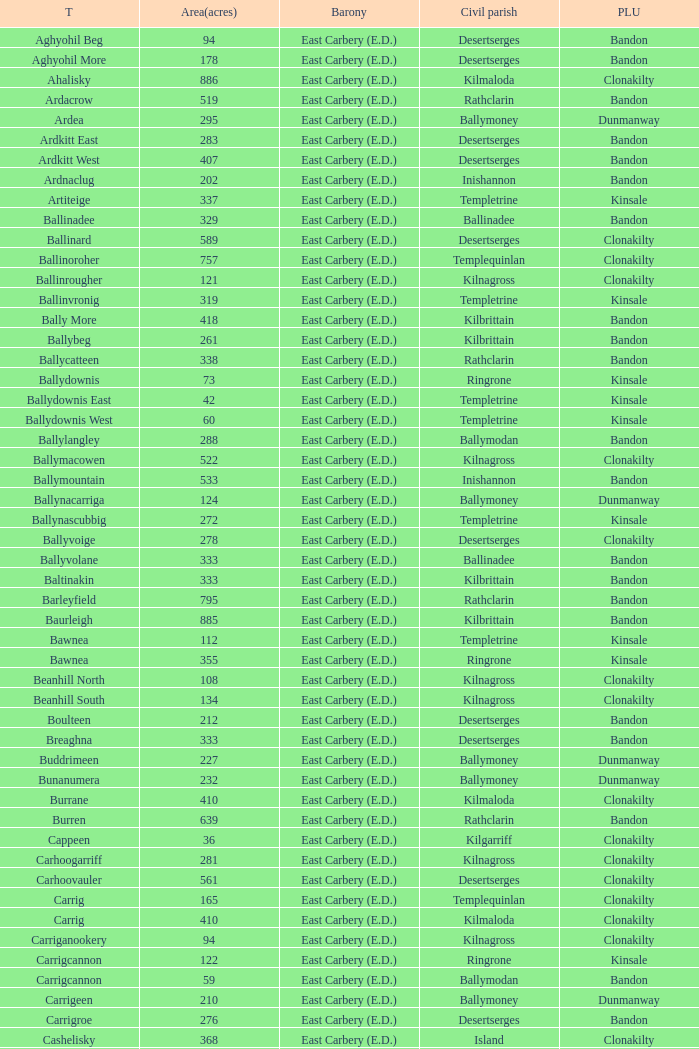What is the poor law union of the Lackenagobidane townland? Clonakilty. Parse the table in full. {'header': ['T', 'Area(acres)', 'Barony', 'Civil parish', 'PLU'], 'rows': [['Aghyohil Beg', '94', 'East Carbery (E.D.)', 'Desertserges', 'Bandon'], ['Aghyohil More', '178', 'East Carbery (E.D.)', 'Desertserges', 'Bandon'], ['Ahalisky', '886', 'East Carbery (E.D.)', 'Kilmaloda', 'Clonakilty'], ['Ardacrow', '519', 'East Carbery (E.D.)', 'Rathclarin', 'Bandon'], ['Ardea', '295', 'East Carbery (E.D.)', 'Ballymoney', 'Dunmanway'], ['Ardkitt East', '283', 'East Carbery (E.D.)', 'Desertserges', 'Bandon'], ['Ardkitt West', '407', 'East Carbery (E.D.)', 'Desertserges', 'Bandon'], ['Ardnaclug', '202', 'East Carbery (E.D.)', 'Inishannon', 'Bandon'], ['Artiteige', '337', 'East Carbery (E.D.)', 'Templetrine', 'Kinsale'], ['Ballinadee', '329', 'East Carbery (E.D.)', 'Ballinadee', 'Bandon'], ['Ballinard', '589', 'East Carbery (E.D.)', 'Desertserges', 'Clonakilty'], ['Ballinoroher', '757', 'East Carbery (E.D.)', 'Templequinlan', 'Clonakilty'], ['Ballinrougher', '121', 'East Carbery (E.D.)', 'Kilnagross', 'Clonakilty'], ['Ballinvronig', '319', 'East Carbery (E.D.)', 'Templetrine', 'Kinsale'], ['Bally More', '418', 'East Carbery (E.D.)', 'Kilbrittain', 'Bandon'], ['Ballybeg', '261', 'East Carbery (E.D.)', 'Kilbrittain', 'Bandon'], ['Ballycatteen', '338', 'East Carbery (E.D.)', 'Rathclarin', 'Bandon'], ['Ballydownis', '73', 'East Carbery (E.D.)', 'Ringrone', 'Kinsale'], ['Ballydownis East', '42', 'East Carbery (E.D.)', 'Templetrine', 'Kinsale'], ['Ballydownis West', '60', 'East Carbery (E.D.)', 'Templetrine', 'Kinsale'], ['Ballylangley', '288', 'East Carbery (E.D.)', 'Ballymodan', 'Bandon'], ['Ballymacowen', '522', 'East Carbery (E.D.)', 'Kilnagross', 'Clonakilty'], ['Ballymountain', '533', 'East Carbery (E.D.)', 'Inishannon', 'Bandon'], ['Ballynacarriga', '124', 'East Carbery (E.D.)', 'Ballymoney', 'Dunmanway'], ['Ballynascubbig', '272', 'East Carbery (E.D.)', 'Templetrine', 'Kinsale'], ['Ballyvoige', '278', 'East Carbery (E.D.)', 'Desertserges', 'Clonakilty'], ['Ballyvolane', '333', 'East Carbery (E.D.)', 'Ballinadee', 'Bandon'], ['Baltinakin', '333', 'East Carbery (E.D.)', 'Kilbrittain', 'Bandon'], ['Barleyfield', '795', 'East Carbery (E.D.)', 'Rathclarin', 'Bandon'], ['Baurleigh', '885', 'East Carbery (E.D.)', 'Kilbrittain', 'Bandon'], ['Bawnea', '112', 'East Carbery (E.D.)', 'Templetrine', 'Kinsale'], ['Bawnea', '355', 'East Carbery (E.D.)', 'Ringrone', 'Kinsale'], ['Beanhill North', '108', 'East Carbery (E.D.)', 'Kilnagross', 'Clonakilty'], ['Beanhill South', '134', 'East Carbery (E.D.)', 'Kilnagross', 'Clonakilty'], ['Boulteen', '212', 'East Carbery (E.D.)', 'Desertserges', 'Bandon'], ['Breaghna', '333', 'East Carbery (E.D.)', 'Desertserges', 'Bandon'], ['Buddrimeen', '227', 'East Carbery (E.D.)', 'Ballymoney', 'Dunmanway'], ['Bunanumera', '232', 'East Carbery (E.D.)', 'Ballymoney', 'Dunmanway'], ['Burrane', '410', 'East Carbery (E.D.)', 'Kilmaloda', 'Clonakilty'], ['Burren', '639', 'East Carbery (E.D.)', 'Rathclarin', 'Bandon'], ['Cappeen', '36', 'East Carbery (E.D.)', 'Kilgarriff', 'Clonakilty'], ['Carhoogarriff', '281', 'East Carbery (E.D.)', 'Kilnagross', 'Clonakilty'], ['Carhoovauler', '561', 'East Carbery (E.D.)', 'Desertserges', 'Clonakilty'], ['Carrig', '165', 'East Carbery (E.D.)', 'Templequinlan', 'Clonakilty'], ['Carrig', '410', 'East Carbery (E.D.)', 'Kilmaloda', 'Clonakilty'], ['Carriganookery', '94', 'East Carbery (E.D.)', 'Kilnagross', 'Clonakilty'], ['Carrigcannon', '122', 'East Carbery (E.D.)', 'Ringrone', 'Kinsale'], ['Carrigcannon', '59', 'East Carbery (E.D.)', 'Ballymodan', 'Bandon'], ['Carrigeen', '210', 'East Carbery (E.D.)', 'Ballymoney', 'Dunmanway'], ['Carrigroe', '276', 'East Carbery (E.D.)', 'Desertserges', 'Bandon'], ['Cashelisky', '368', 'East Carbery (E.D.)', 'Island', 'Clonakilty'], ['Castlederry', '148', 'East Carbery (E.D.)', 'Desertserges', 'Clonakilty'], ['Clashafree', '477', 'East Carbery (E.D.)', 'Ballymodan', 'Bandon'], ['Clashreagh', '132', 'East Carbery (E.D.)', 'Templetrine', 'Kinsale'], ['Clogagh North', '173', 'East Carbery (E.D.)', 'Kilmaloda', 'Clonakilty'], ['Clogagh South', '282', 'East Carbery (E.D.)', 'Kilmaloda', 'Clonakilty'], ['Cloghane', '488', 'East Carbery (E.D.)', 'Ballinadee', 'Bandon'], ['Clogheenavodig', '70', 'East Carbery (E.D.)', 'Ballymodan', 'Bandon'], ['Cloghmacsimon', '258', 'East Carbery (E.D.)', 'Ballymodan', 'Bandon'], ['Cloheen', '360', 'East Carbery (E.D.)', 'Kilgarriff', 'Clonakilty'], ['Cloheen', '80', 'East Carbery (E.D.)', 'Island', 'Clonakilty'], ['Clonbouig', '209', 'East Carbery (E.D.)', 'Templetrine', 'Kinsale'], ['Clonbouig', '219', 'East Carbery (E.D.)', 'Ringrone', 'Kinsale'], ['Cloncouse', '241', 'East Carbery (E.D.)', 'Ballinadee', 'Bandon'], ['Clooncalla Beg', '219', 'East Carbery (E.D.)', 'Rathclarin', 'Bandon'], ['Clooncalla More', '543', 'East Carbery (E.D.)', 'Rathclarin', 'Bandon'], ['Cloonderreen', '291', 'East Carbery (E.D.)', 'Rathclarin', 'Bandon'], ['Coolmain', '450', 'East Carbery (E.D.)', 'Ringrone', 'Kinsale'], ['Corravreeda East', '258', 'East Carbery (E.D.)', 'Ballymodan', 'Bandon'], ['Corravreeda West', '169', 'East Carbery (E.D.)', 'Ballymodan', 'Bandon'], ['Cripplehill', '125', 'East Carbery (E.D.)', 'Ballymodan', 'Bandon'], ['Cripplehill', '93', 'East Carbery (E.D.)', 'Kilbrittain', 'Bandon'], ['Crohane', '91', 'East Carbery (E.D.)', 'Kilnagross', 'Clonakilty'], ['Crohane East', '108', 'East Carbery (E.D.)', 'Desertserges', 'Clonakilty'], ['Crohane West', '69', 'East Carbery (E.D.)', 'Desertserges', 'Clonakilty'], ['Crohane (or Bandon)', '204', 'East Carbery (E.D.)', 'Desertserges', 'Clonakilty'], ['Crohane (or Bandon)', '250', 'East Carbery (E.D.)', 'Kilnagross', 'Clonakilty'], ['Currabeg', '173', 'East Carbery (E.D.)', 'Ballymoney', 'Dunmanway'], ['Curraghcrowly East', '327', 'East Carbery (E.D.)', 'Ballymoney', 'Dunmanway'], ['Curraghcrowly West', '242', 'East Carbery (E.D.)', 'Ballymoney', 'Dunmanway'], ['Curraghgrane More', '110', 'East Carbery (E.D.)', 'Desert', 'Clonakilty'], ['Currane', '156', 'East Carbery (E.D.)', 'Desertserges', 'Clonakilty'], ['Curranure', '362', 'East Carbery (E.D.)', 'Inishannon', 'Bandon'], ['Currarane', '100', 'East Carbery (E.D.)', 'Templetrine', 'Kinsale'], ['Currarane', '271', 'East Carbery (E.D.)', 'Ringrone', 'Kinsale'], ['Derrigra', '177', 'East Carbery (E.D.)', 'Ballymoney', 'Dunmanway'], ['Derrigra West', '320', 'East Carbery (E.D.)', 'Ballymoney', 'Dunmanway'], ['Derry', '140', 'East Carbery (E.D.)', 'Desertserges', 'Clonakilty'], ['Derrymeeleen', '441', 'East Carbery (E.D.)', 'Desertserges', 'Clonakilty'], ['Desert', '339', 'East Carbery (E.D.)', 'Desert', 'Clonakilty'], ['Drombofinny', '86', 'East Carbery (E.D.)', 'Desertserges', 'Bandon'], ['Dromgarriff', '335', 'East Carbery (E.D.)', 'Kilmaloda', 'Clonakilty'], ['Dromgarriff East', '385', 'East Carbery (E.D.)', 'Kilnagross', 'Clonakilty'], ['Dromgarriff West', '138', 'East Carbery (E.D.)', 'Kilnagross', 'Clonakilty'], ['Dromkeen', '673', 'East Carbery (E.D.)', 'Inishannon', 'Bandon'], ['Edencurra', '516', 'East Carbery (E.D.)', 'Ballymoney', 'Dunmanway'], ['Farran', '502', 'East Carbery (E.D.)', 'Kilmaloda', 'Clonakilty'], ['Farranagow', '99', 'East Carbery (E.D.)', 'Inishannon', 'Bandon'], ['Farrannagark', '290', 'East Carbery (E.D.)', 'Rathclarin', 'Bandon'], ['Farrannasheshery', '304', 'East Carbery (E.D.)', 'Desertserges', 'Bandon'], ['Fourcuil', '125', 'East Carbery (E.D.)', 'Kilgarriff', 'Clonakilty'], ['Fourcuil', '244', 'East Carbery (E.D.)', 'Templebryan', 'Clonakilty'], ['Garranbeg', '170', 'East Carbery (E.D.)', 'Ballymodan', 'Bandon'], ['Garraneanasig', '270', 'East Carbery (E.D.)', 'Ringrone', 'Kinsale'], ['Garraneard', '276', 'East Carbery (E.D.)', 'Kilnagross', 'Clonakilty'], ['Garranecore', '144', 'East Carbery (E.D.)', 'Templebryan', 'Clonakilty'], ['Garranecore', '186', 'East Carbery (E.D.)', 'Kilgarriff', 'Clonakilty'], ['Garranefeen', '478', 'East Carbery (E.D.)', 'Rathclarin', 'Bandon'], ['Garraneishal', '121', 'East Carbery (E.D.)', 'Kilnagross', 'Clonakilty'], ['Garranelahan', '126', 'East Carbery (E.D.)', 'Desertserges', 'Bandon'], ['Garranereagh', '398', 'East Carbery (E.D.)', 'Ringrone', 'Kinsale'], ['Garranes', '416', 'East Carbery (E.D.)', 'Desertserges', 'Clonakilty'], ['Garranure', '436', 'East Carbery (E.D.)', 'Ballymoney', 'Dunmanway'], ['Garryndruig', '856', 'East Carbery (E.D.)', 'Rathclarin', 'Bandon'], ['Glan', '194', 'East Carbery (E.D.)', 'Ballymoney', 'Dunmanway'], ['Glanavaud', '98', 'East Carbery (E.D.)', 'Ringrone', 'Kinsale'], ['Glanavirane', '107', 'East Carbery (E.D.)', 'Templetrine', 'Kinsale'], ['Glanavirane', '91', 'East Carbery (E.D.)', 'Ringrone', 'Kinsale'], ['Glanduff', '464', 'East Carbery (E.D.)', 'Rathclarin', 'Bandon'], ['Grillagh', '136', 'East Carbery (E.D.)', 'Kilnagross', 'Clonakilty'], ['Grillagh', '316', 'East Carbery (E.D.)', 'Ballymoney', 'Dunmanway'], ['Hacketstown', '182', 'East Carbery (E.D.)', 'Templetrine', 'Kinsale'], ['Inchafune', '871', 'East Carbery (E.D.)', 'Ballymoney', 'Dunmanway'], ['Inchydoney Island', '474', 'East Carbery (E.D.)', 'Island', 'Clonakilty'], ['Kilbeloge', '216', 'East Carbery (E.D.)', 'Desertserges', 'Clonakilty'], ['Kilbree', '284', 'East Carbery (E.D.)', 'Island', 'Clonakilty'], ['Kilbrittain', '483', 'East Carbery (E.D.)', 'Kilbrittain', 'Bandon'], ['Kilcaskan', '221', 'East Carbery (E.D.)', 'Ballymoney', 'Dunmanway'], ['Kildarra', '463', 'East Carbery (E.D.)', 'Ballinadee', 'Bandon'], ['Kilgarriff', '835', 'East Carbery (E.D.)', 'Kilgarriff', 'Clonakilty'], ['Kilgobbin', '1263', 'East Carbery (E.D.)', 'Ballinadee', 'Bandon'], ['Kill North', '136', 'East Carbery (E.D.)', 'Desertserges', 'Clonakilty'], ['Kill South', '139', 'East Carbery (E.D.)', 'Desertserges', 'Clonakilty'], ['Killanamaul', '220', 'East Carbery (E.D.)', 'Kilbrittain', 'Bandon'], ['Killaneetig', '342', 'East Carbery (E.D.)', 'Ballinadee', 'Bandon'], ['Killavarrig', '708', 'East Carbery (E.D.)', 'Timoleague', 'Clonakilty'], ['Killeen', '309', 'East Carbery (E.D.)', 'Desertserges', 'Clonakilty'], ['Killeens', '132', 'East Carbery (E.D.)', 'Templetrine', 'Kinsale'], ['Kilmacsimon', '219', 'East Carbery (E.D.)', 'Ballinadee', 'Bandon'], ['Kilmaloda', '634', 'East Carbery (E.D.)', 'Kilmaloda', 'Clonakilty'], ['Kilmoylerane North', '306', 'East Carbery (E.D.)', 'Desertserges', 'Clonakilty'], ['Kilmoylerane South', '324', 'East Carbery (E.D.)', 'Desertserges', 'Clonakilty'], ['Kilnameela', '397', 'East Carbery (E.D.)', 'Desertserges', 'Bandon'], ['Kilrush', '189', 'East Carbery (E.D.)', 'Desertserges', 'Bandon'], ['Kilshinahan', '528', 'East Carbery (E.D.)', 'Kilbrittain', 'Bandon'], ['Kilvinane', '199', 'East Carbery (E.D.)', 'Ballymoney', 'Dunmanway'], ['Kilvurra', '356', 'East Carbery (E.D.)', 'Ballymoney', 'Dunmanway'], ['Knockacullen', '381', 'East Carbery (E.D.)', 'Desertserges', 'Clonakilty'], ['Knockaneady', '393', 'East Carbery (E.D.)', 'Ballymoney', 'Dunmanway'], ['Knockaneroe', '127', 'East Carbery (E.D.)', 'Templetrine', 'Kinsale'], ['Knockanreagh', '139', 'East Carbery (E.D.)', 'Ballymodan', 'Bandon'], ['Knockbrown', '312', 'East Carbery (E.D.)', 'Kilbrittain', 'Bandon'], ['Knockbrown', '510', 'East Carbery (E.D.)', 'Kilmaloda', 'Bandon'], ['Knockeenbwee Lower', '213', 'East Carbery (E.D.)', 'Dromdaleague', 'Skibbereen'], ['Knockeenbwee Upper', '229', 'East Carbery (E.D.)', 'Dromdaleague', 'Skibbereen'], ['Knockeencon', '108', 'East Carbery (E.D.)', 'Tullagh', 'Skibbereen'], ['Knockmacool', '241', 'East Carbery (E.D.)', 'Desertserges', 'Bandon'], ['Knocknacurra', '422', 'East Carbery (E.D.)', 'Ballinadee', 'Bandon'], ['Knocknagappul', '507', 'East Carbery (E.D.)', 'Ballinadee', 'Bandon'], ['Knocknanuss', '394', 'East Carbery (E.D.)', 'Desertserges', 'Clonakilty'], ['Knocknastooka', '118', 'East Carbery (E.D.)', 'Desertserges', 'Bandon'], ['Knockroe', '601', 'East Carbery (E.D.)', 'Inishannon', 'Bandon'], ['Knocks', '540', 'East Carbery (E.D.)', 'Desertserges', 'Clonakilty'], ['Knockskagh', '489', 'East Carbery (E.D.)', 'Kilgarriff', 'Clonakilty'], ['Knoppoge', '567', 'East Carbery (E.D.)', 'Kilbrittain', 'Bandon'], ['Lackanalooha', '209', 'East Carbery (E.D.)', 'Kilnagross', 'Clonakilty'], ['Lackenagobidane', '48', 'East Carbery (E.D.)', 'Island', 'Clonakilty'], ['Lisbehegh', '255', 'East Carbery (E.D.)', 'Desertserges', 'Clonakilty'], ['Lisheen', '44', 'East Carbery (E.D.)', 'Templetrine', 'Kinsale'], ['Lisheenaleen', '267', 'East Carbery (E.D.)', 'Rathclarin', 'Bandon'], ['Lisnacunna', '529', 'East Carbery (E.D.)', 'Desertserges', 'Bandon'], ['Lisroe', '91', 'East Carbery (E.D.)', 'Kilgarriff', 'Clonakilty'], ['Lissaphooca', '513', 'East Carbery (E.D.)', 'Ballymodan', 'Bandon'], ['Lisselane', '429', 'East Carbery (E.D.)', 'Kilnagross', 'Clonakilty'], ['Madame', '273', 'East Carbery (E.D.)', 'Kilmaloda', 'Clonakilty'], ['Madame', '41', 'East Carbery (E.D.)', 'Kilnagross', 'Clonakilty'], ['Maulbrack East', '100', 'East Carbery (E.D.)', 'Desertserges', 'Bandon'], ['Maulbrack West', '242', 'East Carbery (E.D.)', 'Desertserges', 'Bandon'], ['Maulmane', '219', 'East Carbery (E.D.)', 'Kilbrittain', 'Bandon'], ['Maulnageragh', '135', 'East Carbery (E.D.)', 'Kilnagross', 'Clonakilty'], ['Maulnarouga North', '81', 'East Carbery (E.D.)', 'Desertserges', 'Bandon'], ['Maulnarouga South', '374', 'East Carbery (E.D.)', 'Desertserges', 'Bandon'], ['Maulnaskehy', '14', 'East Carbery (E.D.)', 'Kilgarriff', 'Clonakilty'], ['Maulrour', '244', 'East Carbery (E.D.)', 'Desertserges', 'Clonakilty'], ['Maulrour', '340', 'East Carbery (E.D.)', 'Kilmaloda', 'Clonakilty'], ['Maulskinlahane', '245', 'East Carbery (E.D.)', 'Kilbrittain', 'Bandon'], ['Miles', '268', 'East Carbery (E.D.)', 'Kilgarriff', 'Clonakilty'], ['Moanarone', '235', 'East Carbery (E.D.)', 'Ballymodan', 'Bandon'], ['Monteen', '589', 'East Carbery (E.D.)', 'Kilmaloda', 'Clonakilty'], ['Phale Lower', '287', 'East Carbery (E.D.)', 'Ballymoney', 'Dunmanway'], ['Phale Upper', '234', 'East Carbery (E.D.)', 'Ballymoney', 'Dunmanway'], ['Ratharoon East', '810', 'East Carbery (E.D.)', 'Ballinadee', 'Bandon'], ['Ratharoon West', '383', 'East Carbery (E.D.)', 'Ballinadee', 'Bandon'], ['Rathdrought', '1242', 'East Carbery (E.D.)', 'Ballinadee', 'Bandon'], ['Reengarrigeen', '560', 'East Carbery (E.D.)', 'Kilmaloda', 'Clonakilty'], ['Reenroe', '123', 'East Carbery (E.D.)', 'Kilgarriff', 'Clonakilty'], ['Rochestown', '104', 'East Carbery (E.D.)', 'Templetrine', 'Kinsale'], ['Rockfort', '308', 'East Carbery (E.D.)', 'Brinny', 'Bandon'], ['Rockhouse', '82', 'East Carbery (E.D.)', 'Ballinadee', 'Bandon'], ['Scartagh', '186', 'East Carbery (E.D.)', 'Kilgarriff', 'Clonakilty'], ['Shanakill', '197', 'East Carbery (E.D.)', 'Rathclarin', 'Bandon'], ['Shanaway East', '386', 'East Carbery (E.D.)', 'Ballymoney', 'Dunmanway'], ['Shanaway Middle', '296', 'East Carbery (E.D.)', 'Ballymoney', 'Dunmanway'], ['Shanaway West', '266', 'East Carbery (E.D.)', 'Ballymoney', 'Dunmanway'], ['Skeaf', '452', 'East Carbery (E.D.)', 'Kilmaloda', 'Clonakilty'], ['Skeaf East', '371', 'East Carbery (E.D.)', 'Kilmaloda', 'Clonakilty'], ['Skeaf West', '477', 'East Carbery (E.D.)', 'Kilmaloda', 'Clonakilty'], ['Skevanish', '359', 'East Carbery (E.D.)', 'Inishannon', 'Bandon'], ['Steilaneigh', '42', 'East Carbery (E.D.)', 'Templetrine', 'Kinsale'], ['Tawnies Lower', '238', 'East Carbery (E.D.)', 'Kilgarriff', 'Clonakilty'], ['Tawnies Upper', '321', 'East Carbery (E.D.)', 'Kilgarriff', 'Clonakilty'], ['Templebryan North', '436', 'East Carbery (E.D.)', 'Templebryan', 'Clonakilty'], ['Templebryan South', '363', 'East Carbery (E.D.)', 'Templebryan', 'Clonakilty'], ['Tullig', '135', 'East Carbery (E.D.)', 'Kilmaloda', 'Clonakilty'], ['Tullyland', '348', 'East Carbery (E.D.)', 'Ballymodan', 'Bandon'], ['Tullyland', '506', 'East Carbery (E.D.)', 'Ballinadee', 'Bandon'], ['Tullymurrihy', '665', 'East Carbery (E.D.)', 'Desertserges', 'Bandon'], ['Youghals', '109', 'East Carbery (E.D.)', 'Island', 'Clonakilty']]} 